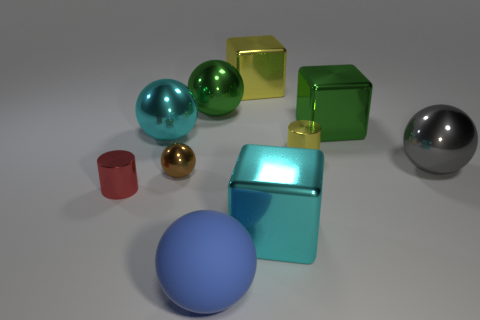Subtract all large blue spheres. How many spheres are left? 4 Subtract 1 blocks. How many blocks are left? 2 Subtract all blue spheres. How many spheres are left? 4 Subtract all brown blocks. Subtract all cyan cylinders. How many blocks are left? 3 Subtract all cylinders. How many objects are left? 8 Subtract all blue spheres. Subtract all small objects. How many objects are left? 6 Add 9 large blue matte objects. How many large blue matte objects are left? 10 Add 7 small matte spheres. How many small matte spheres exist? 7 Subtract 0 purple blocks. How many objects are left? 10 